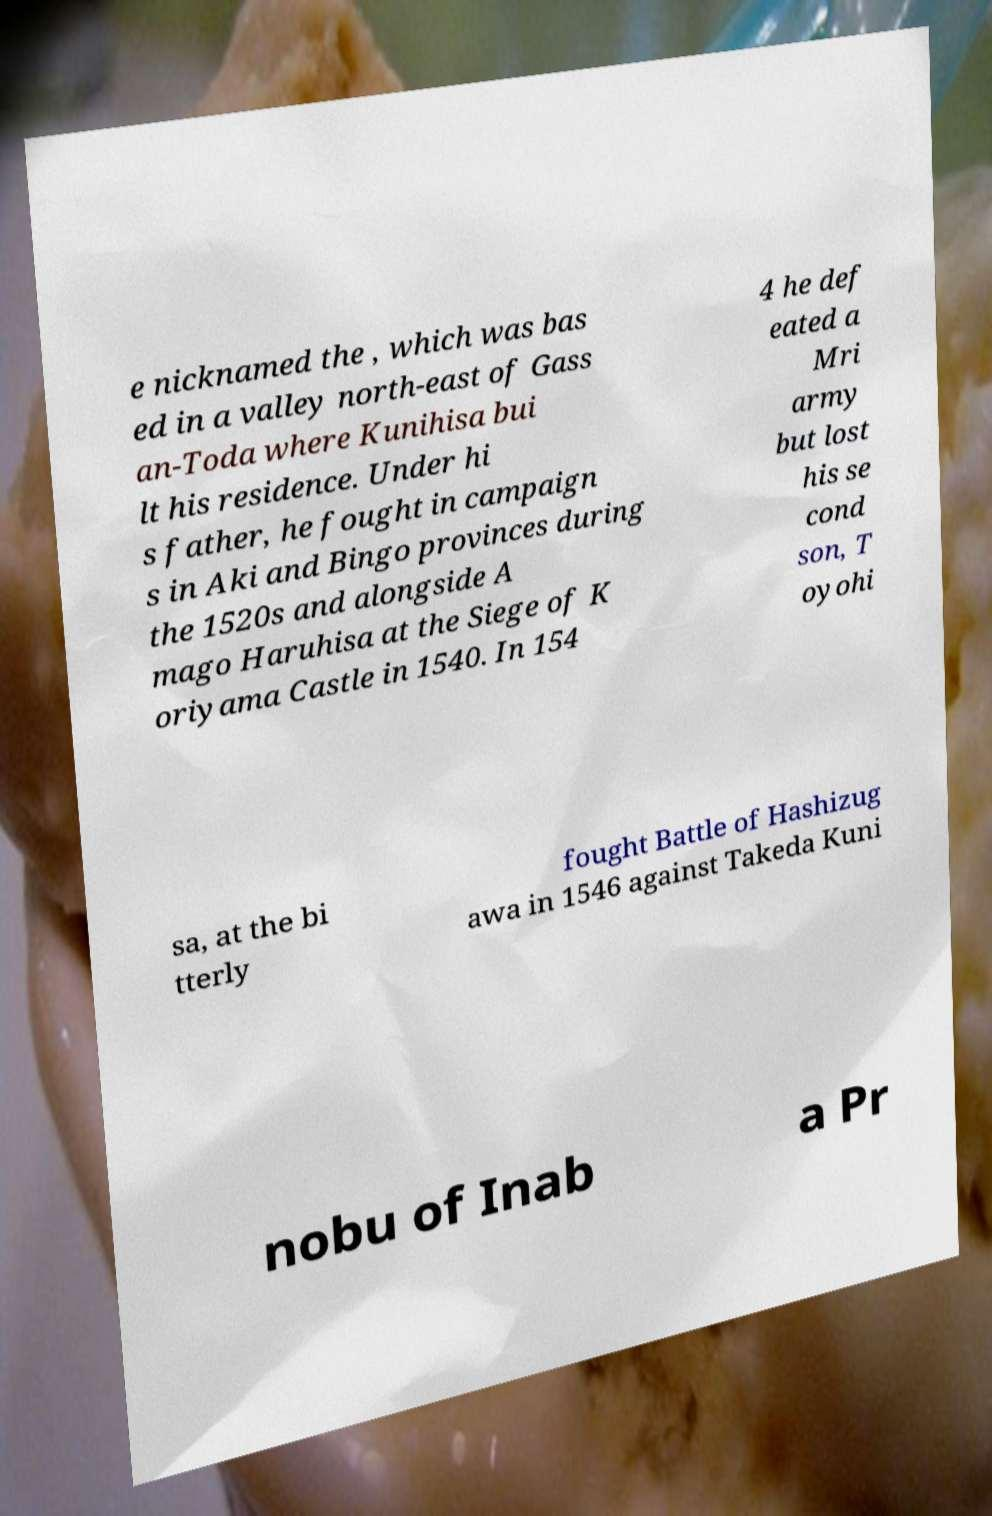For documentation purposes, I need the text within this image transcribed. Could you provide that? e nicknamed the , which was bas ed in a valley north-east of Gass an-Toda where Kunihisa bui lt his residence. Under hi s father, he fought in campaign s in Aki and Bingo provinces during the 1520s and alongside A mago Haruhisa at the Siege of K oriyama Castle in 1540. In 154 4 he def eated a Mri army but lost his se cond son, T oyohi sa, at the bi tterly fought Battle of Hashizug awa in 1546 against Takeda Kuni nobu of Inab a Pr 